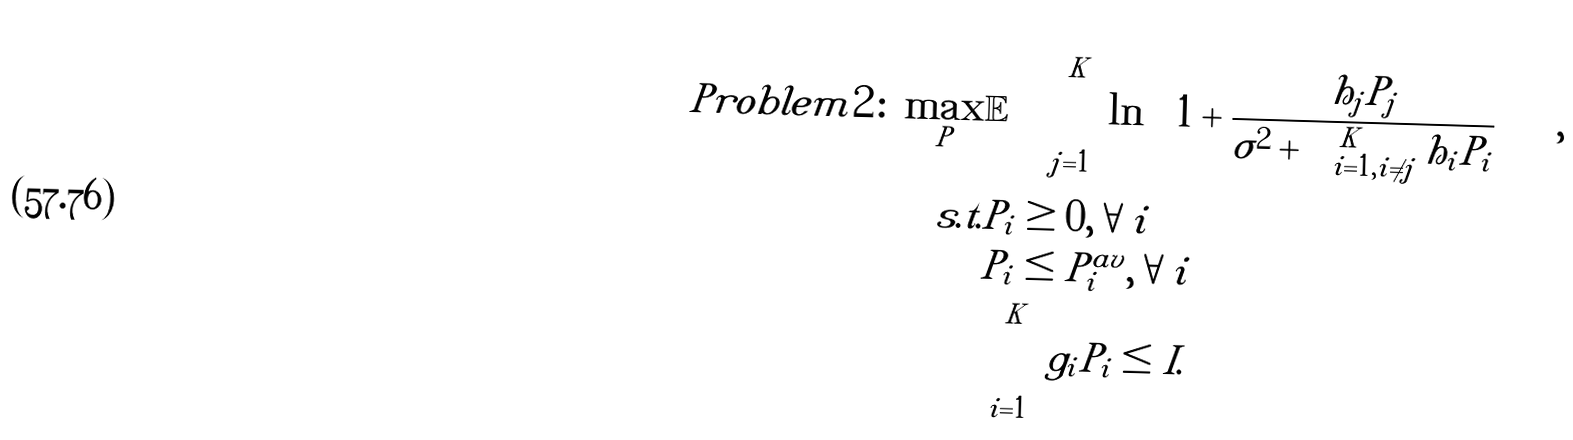<formula> <loc_0><loc_0><loc_500><loc_500>P r o b l e m 2 \colon \max _ { P } & \mathbb { E } \left [ \sum _ { j = 1 } ^ { K } \ln \left ( 1 + \frac { h _ { j } P _ { j } } { \sigma ^ { 2 } + \sum _ { i = 1 , i \neq j } ^ { K } h _ { i } P _ { i } } \right ) \right ] , \\ s . t . & P _ { i } \geq 0 , \forall i \\ & P _ { i } \leq P _ { i } ^ { a v } , \forall i \\ & \sum _ { i = 1 } ^ { K } g _ { i } P _ { i } \leq I .</formula> 